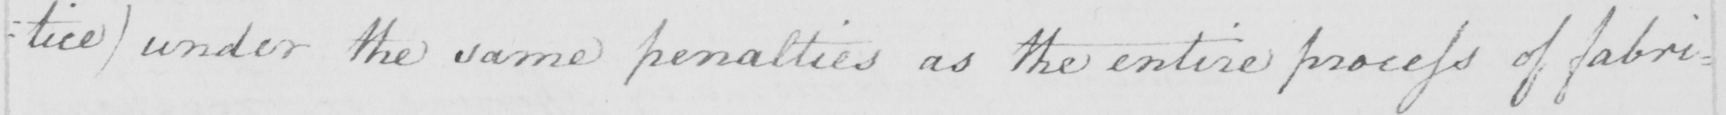Can you tell me what this handwritten text says? : tice )  under the same penalties as the entire process of fabri= 